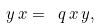Convert formula to latex. <formula><loc_0><loc_0><loc_500><loc_500>y \, x = \ q \, x \, y ,</formula> 